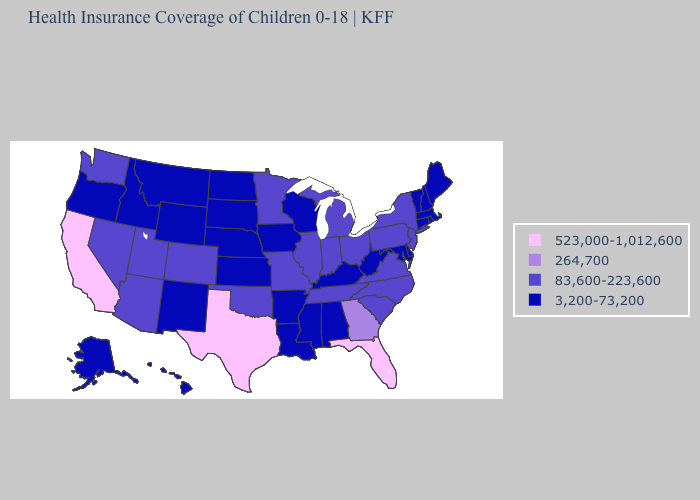Name the states that have a value in the range 523,000-1,012,600?
Keep it brief. California, Florida, Texas. What is the lowest value in the USA?
Write a very short answer. 3,200-73,200. What is the value of Louisiana?
Give a very brief answer. 3,200-73,200. Which states hav the highest value in the Northeast?
Short answer required. New Jersey, New York, Pennsylvania. What is the value of New York?
Give a very brief answer. 83,600-223,600. What is the highest value in the Northeast ?
Be succinct. 83,600-223,600. Does Alaska have a lower value than Michigan?
Quick response, please. Yes. What is the lowest value in the MidWest?
Be succinct. 3,200-73,200. What is the value of Idaho?
Short answer required. 3,200-73,200. What is the highest value in states that border Michigan?
Concise answer only. 83,600-223,600. Among the states that border New Mexico , which have the highest value?
Write a very short answer. Texas. Does Arizona have the lowest value in the USA?
Quick response, please. No. Among the states that border Kansas , does Nebraska have the lowest value?
Write a very short answer. Yes. Among the states that border Delaware , does Maryland have the lowest value?
Quick response, please. Yes. Does Texas have the highest value in the USA?
Be succinct. Yes. 